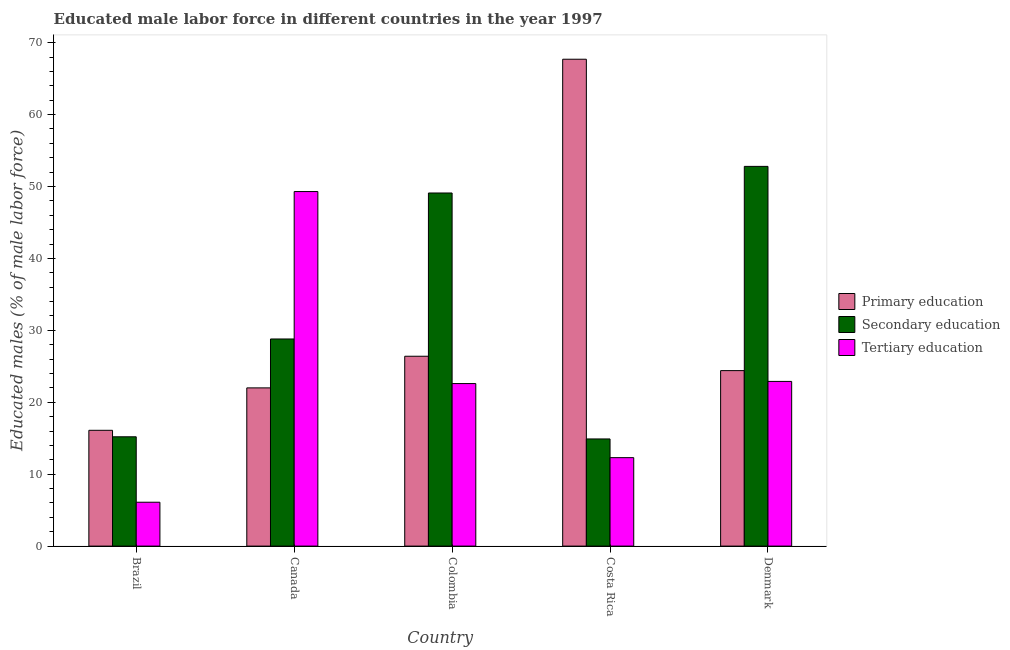How many groups of bars are there?
Ensure brevity in your answer.  5. Are the number of bars on each tick of the X-axis equal?
Your response must be concise. Yes. How many bars are there on the 5th tick from the left?
Make the answer very short. 3. In how many cases, is the number of bars for a given country not equal to the number of legend labels?
Your response must be concise. 0. Across all countries, what is the maximum percentage of male labor force who received tertiary education?
Provide a short and direct response. 49.3. Across all countries, what is the minimum percentage of male labor force who received tertiary education?
Give a very brief answer. 6.1. In which country was the percentage of male labor force who received tertiary education minimum?
Offer a very short reply. Brazil. What is the total percentage of male labor force who received secondary education in the graph?
Provide a short and direct response. 160.8. What is the difference between the percentage of male labor force who received tertiary education in Canada and that in Colombia?
Offer a terse response. 26.7. What is the average percentage of male labor force who received primary education per country?
Offer a very short reply. 31.32. What is the difference between the percentage of male labor force who received primary education and percentage of male labor force who received tertiary education in Denmark?
Keep it short and to the point. 1.5. What is the ratio of the percentage of male labor force who received primary education in Brazil to that in Canada?
Your answer should be compact. 0.73. Is the percentage of male labor force who received primary education in Canada less than that in Denmark?
Your response must be concise. Yes. Is the difference between the percentage of male labor force who received tertiary education in Brazil and Canada greater than the difference between the percentage of male labor force who received secondary education in Brazil and Canada?
Give a very brief answer. No. What is the difference between the highest and the second highest percentage of male labor force who received secondary education?
Make the answer very short. 3.7. What is the difference between the highest and the lowest percentage of male labor force who received secondary education?
Give a very brief answer. 37.9. In how many countries, is the percentage of male labor force who received primary education greater than the average percentage of male labor force who received primary education taken over all countries?
Ensure brevity in your answer.  1. Is the sum of the percentage of male labor force who received secondary education in Costa Rica and Denmark greater than the maximum percentage of male labor force who received tertiary education across all countries?
Keep it short and to the point. Yes. What does the 3rd bar from the left in Costa Rica represents?
Your answer should be compact. Tertiary education. How many bars are there?
Your answer should be compact. 15. What is the difference between two consecutive major ticks on the Y-axis?
Provide a succinct answer. 10. Are the values on the major ticks of Y-axis written in scientific E-notation?
Make the answer very short. No. Does the graph contain grids?
Make the answer very short. No. How are the legend labels stacked?
Provide a short and direct response. Vertical. What is the title of the graph?
Offer a terse response. Educated male labor force in different countries in the year 1997. Does "Slovak Republic" appear as one of the legend labels in the graph?
Your answer should be very brief. No. What is the label or title of the X-axis?
Keep it short and to the point. Country. What is the label or title of the Y-axis?
Offer a very short reply. Educated males (% of male labor force). What is the Educated males (% of male labor force) of Primary education in Brazil?
Keep it short and to the point. 16.1. What is the Educated males (% of male labor force) in Secondary education in Brazil?
Keep it short and to the point. 15.2. What is the Educated males (% of male labor force) in Tertiary education in Brazil?
Give a very brief answer. 6.1. What is the Educated males (% of male labor force) of Primary education in Canada?
Keep it short and to the point. 22. What is the Educated males (% of male labor force) of Secondary education in Canada?
Provide a succinct answer. 28.8. What is the Educated males (% of male labor force) in Tertiary education in Canada?
Ensure brevity in your answer.  49.3. What is the Educated males (% of male labor force) of Primary education in Colombia?
Your answer should be compact. 26.4. What is the Educated males (% of male labor force) in Secondary education in Colombia?
Your answer should be very brief. 49.1. What is the Educated males (% of male labor force) of Tertiary education in Colombia?
Your answer should be compact. 22.6. What is the Educated males (% of male labor force) of Primary education in Costa Rica?
Offer a terse response. 67.7. What is the Educated males (% of male labor force) of Secondary education in Costa Rica?
Provide a succinct answer. 14.9. What is the Educated males (% of male labor force) of Tertiary education in Costa Rica?
Make the answer very short. 12.3. What is the Educated males (% of male labor force) of Primary education in Denmark?
Offer a very short reply. 24.4. What is the Educated males (% of male labor force) of Secondary education in Denmark?
Provide a short and direct response. 52.8. What is the Educated males (% of male labor force) of Tertiary education in Denmark?
Keep it short and to the point. 22.9. Across all countries, what is the maximum Educated males (% of male labor force) of Primary education?
Offer a terse response. 67.7. Across all countries, what is the maximum Educated males (% of male labor force) in Secondary education?
Give a very brief answer. 52.8. Across all countries, what is the maximum Educated males (% of male labor force) in Tertiary education?
Provide a short and direct response. 49.3. Across all countries, what is the minimum Educated males (% of male labor force) of Primary education?
Your response must be concise. 16.1. Across all countries, what is the minimum Educated males (% of male labor force) in Secondary education?
Keep it short and to the point. 14.9. Across all countries, what is the minimum Educated males (% of male labor force) of Tertiary education?
Your answer should be compact. 6.1. What is the total Educated males (% of male labor force) of Primary education in the graph?
Provide a short and direct response. 156.6. What is the total Educated males (% of male labor force) in Secondary education in the graph?
Provide a short and direct response. 160.8. What is the total Educated males (% of male labor force) of Tertiary education in the graph?
Offer a terse response. 113.2. What is the difference between the Educated males (% of male labor force) in Primary education in Brazil and that in Canada?
Make the answer very short. -5.9. What is the difference between the Educated males (% of male labor force) in Secondary education in Brazil and that in Canada?
Offer a very short reply. -13.6. What is the difference between the Educated males (% of male labor force) in Tertiary education in Brazil and that in Canada?
Offer a terse response. -43.2. What is the difference between the Educated males (% of male labor force) of Primary education in Brazil and that in Colombia?
Your answer should be compact. -10.3. What is the difference between the Educated males (% of male labor force) in Secondary education in Brazil and that in Colombia?
Offer a very short reply. -33.9. What is the difference between the Educated males (% of male labor force) in Tertiary education in Brazil and that in Colombia?
Your response must be concise. -16.5. What is the difference between the Educated males (% of male labor force) of Primary education in Brazil and that in Costa Rica?
Make the answer very short. -51.6. What is the difference between the Educated males (% of male labor force) in Tertiary education in Brazil and that in Costa Rica?
Your answer should be very brief. -6.2. What is the difference between the Educated males (% of male labor force) in Primary education in Brazil and that in Denmark?
Make the answer very short. -8.3. What is the difference between the Educated males (% of male labor force) of Secondary education in Brazil and that in Denmark?
Make the answer very short. -37.6. What is the difference between the Educated males (% of male labor force) of Tertiary education in Brazil and that in Denmark?
Give a very brief answer. -16.8. What is the difference between the Educated males (% of male labor force) of Primary education in Canada and that in Colombia?
Give a very brief answer. -4.4. What is the difference between the Educated males (% of male labor force) of Secondary education in Canada and that in Colombia?
Keep it short and to the point. -20.3. What is the difference between the Educated males (% of male labor force) of Tertiary education in Canada and that in Colombia?
Provide a short and direct response. 26.7. What is the difference between the Educated males (% of male labor force) in Primary education in Canada and that in Costa Rica?
Your response must be concise. -45.7. What is the difference between the Educated males (% of male labor force) of Secondary education in Canada and that in Costa Rica?
Provide a short and direct response. 13.9. What is the difference between the Educated males (% of male labor force) of Tertiary education in Canada and that in Denmark?
Your answer should be very brief. 26.4. What is the difference between the Educated males (% of male labor force) of Primary education in Colombia and that in Costa Rica?
Your response must be concise. -41.3. What is the difference between the Educated males (% of male labor force) of Secondary education in Colombia and that in Costa Rica?
Offer a terse response. 34.2. What is the difference between the Educated males (% of male labor force) in Secondary education in Colombia and that in Denmark?
Your answer should be very brief. -3.7. What is the difference between the Educated males (% of male labor force) in Tertiary education in Colombia and that in Denmark?
Offer a very short reply. -0.3. What is the difference between the Educated males (% of male labor force) in Primary education in Costa Rica and that in Denmark?
Make the answer very short. 43.3. What is the difference between the Educated males (% of male labor force) of Secondary education in Costa Rica and that in Denmark?
Offer a terse response. -37.9. What is the difference between the Educated males (% of male labor force) in Tertiary education in Costa Rica and that in Denmark?
Your answer should be very brief. -10.6. What is the difference between the Educated males (% of male labor force) of Primary education in Brazil and the Educated males (% of male labor force) of Secondary education in Canada?
Provide a short and direct response. -12.7. What is the difference between the Educated males (% of male labor force) in Primary education in Brazil and the Educated males (% of male labor force) in Tertiary education in Canada?
Make the answer very short. -33.2. What is the difference between the Educated males (% of male labor force) of Secondary education in Brazil and the Educated males (% of male labor force) of Tertiary education in Canada?
Your response must be concise. -34.1. What is the difference between the Educated males (% of male labor force) of Primary education in Brazil and the Educated males (% of male labor force) of Secondary education in Colombia?
Offer a very short reply. -33. What is the difference between the Educated males (% of male labor force) of Primary education in Brazil and the Educated males (% of male labor force) of Tertiary education in Colombia?
Provide a succinct answer. -6.5. What is the difference between the Educated males (% of male labor force) of Secondary education in Brazil and the Educated males (% of male labor force) of Tertiary education in Colombia?
Keep it short and to the point. -7.4. What is the difference between the Educated males (% of male labor force) in Primary education in Brazil and the Educated males (% of male labor force) in Tertiary education in Costa Rica?
Keep it short and to the point. 3.8. What is the difference between the Educated males (% of male labor force) of Primary education in Brazil and the Educated males (% of male labor force) of Secondary education in Denmark?
Give a very brief answer. -36.7. What is the difference between the Educated males (% of male labor force) of Primary education in Canada and the Educated males (% of male labor force) of Secondary education in Colombia?
Ensure brevity in your answer.  -27.1. What is the difference between the Educated males (% of male labor force) of Primary education in Canada and the Educated males (% of male labor force) of Tertiary education in Colombia?
Make the answer very short. -0.6. What is the difference between the Educated males (% of male labor force) in Primary education in Canada and the Educated males (% of male labor force) in Secondary education in Costa Rica?
Your answer should be very brief. 7.1. What is the difference between the Educated males (% of male labor force) of Secondary education in Canada and the Educated males (% of male labor force) of Tertiary education in Costa Rica?
Your response must be concise. 16.5. What is the difference between the Educated males (% of male labor force) in Primary education in Canada and the Educated males (% of male labor force) in Secondary education in Denmark?
Your answer should be compact. -30.8. What is the difference between the Educated males (% of male labor force) of Secondary education in Colombia and the Educated males (% of male labor force) of Tertiary education in Costa Rica?
Your answer should be compact. 36.8. What is the difference between the Educated males (% of male labor force) of Primary education in Colombia and the Educated males (% of male labor force) of Secondary education in Denmark?
Provide a short and direct response. -26.4. What is the difference between the Educated males (% of male labor force) in Primary education in Colombia and the Educated males (% of male labor force) in Tertiary education in Denmark?
Offer a terse response. 3.5. What is the difference between the Educated males (% of male labor force) of Secondary education in Colombia and the Educated males (% of male labor force) of Tertiary education in Denmark?
Offer a very short reply. 26.2. What is the difference between the Educated males (% of male labor force) in Primary education in Costa Rica and the Educated males (% of male labor force) in Secondary education in Denmark?
Provide a short and direct response. 14.9. What is the difference between the Educated males (% of male labor force) of Primary education in Costa Rica and the Educated males (% of male labor force) of Tertiary education in Denmark?
Offer a very short reply. 44.8. What is the average Educated males (% of male labor force) of Primary education per country?
Ensure brevity in your answer.  31.32. What is the average Educated males (% of male labor force) of Secondary education per country?
Provide a short and direct response. 32.16. What is the average Educated males (% of male labor force) in Tertiary education per country?
Keep it short and to the point. 22.64. What is the difference between the Educated males (% of male labor force) of Primary education and Educated males (% of male labor force) of Secondary education in Brazil?
Provide a succinct answer. 0.9. What is the difference between the Educated males (% of male labor force) of Secondary education and Educated males (% of male labor force) of Tertiary education in Brazil?
Give a very brief answer. 9.1. What is the difference between the Educated males (% of male labor force) of Primary education and Educated males (% of male labor force) of Tertiary education in Canada?
Provide a succinct answer. -27.3. What is the difference between the Educated males (% of male labor force) of Secondary education and Educated males (% of male labor force) of Tertiary education in Canada?
Give a very brief answer. -20.5. What is the difference between the Educated males (% of male labor force) of Primary education and Educated males (% of male labor force) of Secondary education in Colombia?
Make the answer very short. -22.7. What is the difference between the Educated males (% of male labor force) in Primary education and Educated males (% of male labor force) in Tertiary education in Colombia?
Your answer should be compact. 3.8. What is the difference between the Educated males (% of male labor force) of Primary education and Educated males (% of male labor force) of Secondary education in Costa Rica?
Provide a succinct answer. 52.8. What is the difference between the Educated males (% of male labor force) of Primary education and Educated males (% of male labor force) of Tertiary education in Costa Rica?
Keep it short and to the point. 55.4. What is the difference between the Educated males (% of male labor force) in Secondary education and Educated males (% of male labor force) in Tertiary education in Costa Rica?
Provide a short and direct response. 2.6. What is the difference between the Educated males (% of male labor force) in Primary education and Educated males (% of male labor force) in Secondary education in Denmark?
Make the answer very short. -28.4. What is the difference between the Educated males (% of male labor force) of Primary education and Educated males (% of male labor force) of Tertiary education in Denmark?
Your answer should be very brief. 1.5. What is the difference between the Educated males (% of male labor force) in Secondary education and Educated males (% of male labor force) in Tertiary education in Denmark?
Make the answer very short. 29.9. What is the ratio of the Educated males (% of male labor force) in Primary education in Brazil to that in Canada?
Your response must be concise. 0.73. What is the ratio of the Educated males (% of male labor force) in Secondary education in Brazil to that in Canada?
Make the answer very short. 0.53. What is the ratio of the Educated males (% of male labor force) of Tertiary education in Brazil to that in Canada?
Give a very brief answer. 0.12. What is the ratio of the Educated males (% of male labor force) in Primary education in Brazil to that in Colombia?
Your response must be concise. 0.61. What is the ratio of the Educated males (% of male labor force) of Secondary education in Brazil to that in Colombia?
Ensure brevity in your answer.  0.31. What is the ratio of the Educated males (% of male labor force) in Tertiary education in Brazil to that in Colombia?
Offer a very short reply. 0.27. What is the ratio of the Educated males (% of male labor force) in Primary education in Brazil to that in Costa Rica?
Offer a very short reply. 0.24. What is the ratio of the Educated males (% of male labor force) of Secondary education in Brazil to that in Costa Rica?
Give a very brief answer. 1.02. What is the ratio of the Educated males (% of male labor force) in Tertiary education in Brazil to that in Costa Rica?
Your answer should be compact. 0.5. What is the ratio of the Educated males (% of male labor force) in Primary education in Brazil to that in Denmark?
Your answer should be compact. 0.66. What is the ratio of the Educated males (% of male labor force) of Secondary education in Brazil to that in Denmark?
Ensure brevity in your answer.  0.29. What is the ratio of the Educated males (% of male labor force) in Tertiary education in Brazil to that in Denmark?
Keep it short and to the point. 0.27. What is the ratio of the Educated males (% of male labor force) in Secondary education in Canada to that in Colombia?
Ensure brevity in your answer.  0.59. What is the ratio of the Educated males (% of male labor force) of Tertiary education in Canada to that in Colombia?
Provide a succinct answer. 2.18. What is the ratio of the Educated males (% of male labor force) in Primary education in Canada to that in Costa Rica?
Offer a very short reply. 0.33. What is the ratio of the Educated males (% of male labor force) of Secondary education in Canada to that in Costa Rica?
Provide a succinct answer. 1.93. What is the ratio of the Educated males (% of male labor force) in Tertiary education in Canada to that in Costa Rica?
Give a very brief answer. 4.01. What is the ratio of the Educated males (% of male labor force) of Primary education in Canada to that in Denmark?
Your answer should be very brief. 0.9. What is the ratio of the Educated males (% of male labor force) of Secondary education in Canada to that in Denmark?
Give a very brief answer. 0.55. What is the ratio of the Educated males (% of male labor force) of Tertiary education in Canada to that in Denmark?
Your response must be concise. 2.15. What is the ratio of the Educated males (% of male labor force) in Primary education in Colombia to that in Costa Rica?
Keep it short and to the point. 0.39. What is the ratio of the Educated males (% of male labor force) of Secondary education in Colombia to that in Costa Rica?
Your response must be concise. 3.3. What is the ratio of the Educated males (% of male labor force) in Tertiary education in Colombia to that in Costa Rica?
Ensure brevity in your answer.  1.84. What is the ratio of the Educated males (% of male labor force) of Primary education in Colombia to that in Denmark?
Provide a short and direct response. 1.08. What is the ratio of the Educated males (% of male labor force) in Secondary education in Colombia to that in Denmark?
Your response must be concise. 0.93. What is the ratio of the Educated males (% of male labor force) in Tertiary education in Colombia to that in Denmark?
Provide a short and direct response. 0.99. What is the ratio of the Educated males (% of male labor force) of Primary education in Costa Rica to that in Denmark?
Your response must be concise. 2.77. What is the ratio of the Educated males (% of male labor force) in Secondary education in Costa Rica to that in Denmark?
Provide a succinct answer. 0.28. What is the ratio of the Educated males (% of male labor force) in Tertiary education in Costa Rica to that in Denmark?
Make the answer very short. 0.54. What is the difference between the highest and the second highest Educated males (% of male labor force) in Primary education?
Offer a very short reply. 41.3. What is the difference between the highest and the second highest Educated males (% of male labor force) of Tertiary education?
Keep it short and to the point. 26.4. What is the difference between the highest and the lowest Educated males (% of male labor force) in Primary education?
Your answer should be very brief. 51.6. What is the difference between the highest and the lowest Educated males (% of male labor force) of Secondary education?
Give a very brief answer. 37.9. What is the difference between the highest and the lowest Educated males (% of male labor force) in Tertiary education?
Your response must be concise. 43.2. 